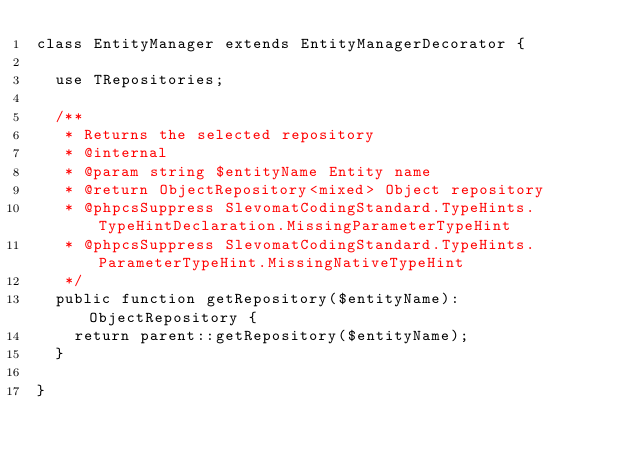<code> <loc_0><loc_0><loc_500><loc_500><_PHP_>class EntityManager extends EntityManagerDecorator {

	use TRepositories;

	/**
	 * Returns the selected repository
	 * @internal
	 * @param string $entityName Entity name
	 * @return ObjectRepository<mixed> Object repository
	 * @phpcsSuppress SlevomatCodingStandard.TypeHints.TypeHintDeclaration.MissingParameterTypeHint
	 * @phpcsSuppress SlevomatCodingStandard.TypeHints.ParameterTypeHint.MissingNativeTypeHint
	 */
	public function getRepository($entityName): ObjectRepository {
		return parent::getRepository($entityName);
	}

}
</code> 